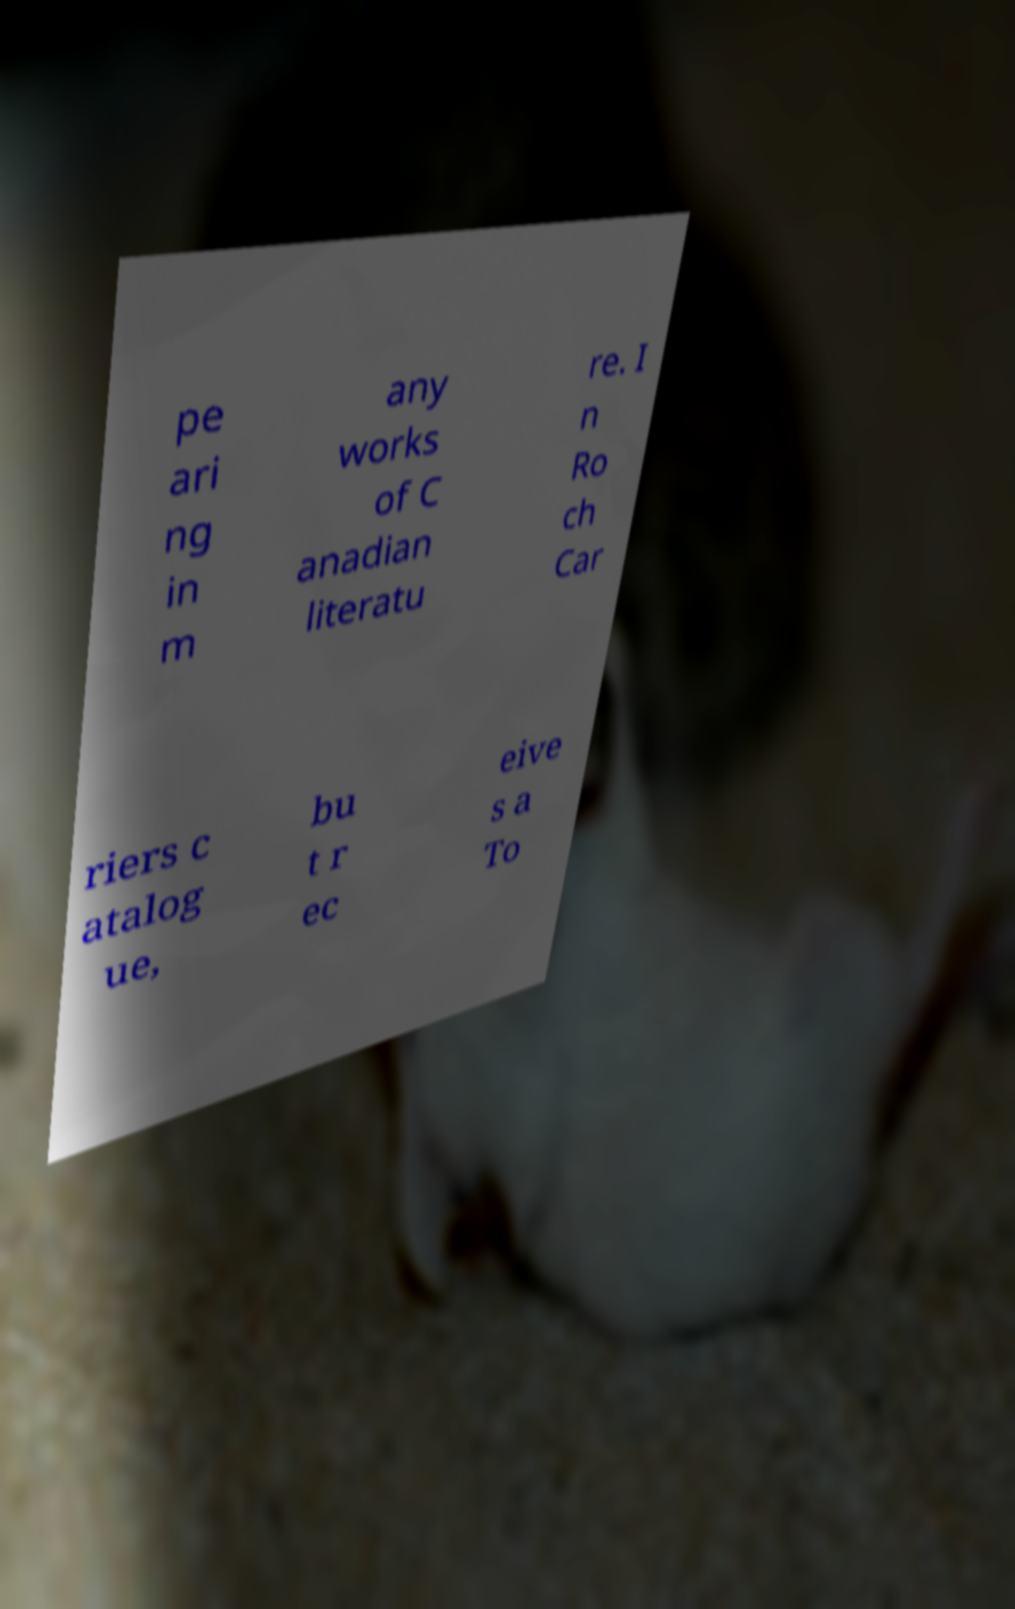For documentation purposes, I need the text within this image transcribed. Could you provide that? pe ari ng in m any works of C anadian literatu re. I n Ro ch Car riers c atalog ue, bu t r ec eive s a To 